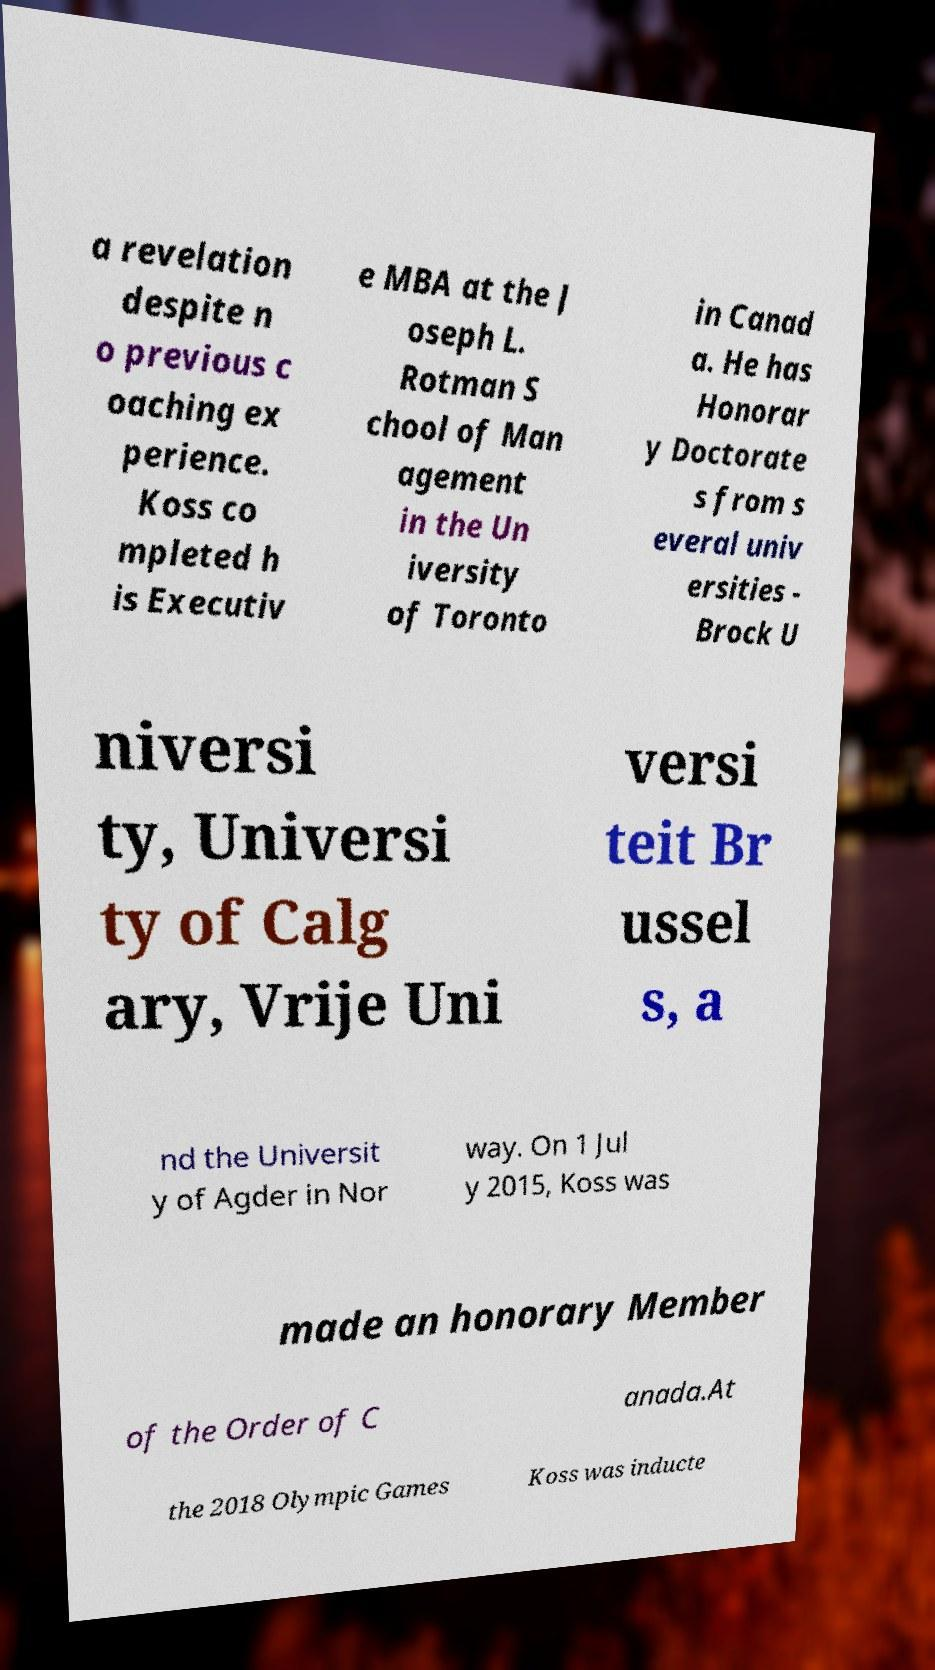Can you read and provide the text displayed in the image?This photo seems to have some interesting text. Can you extract and type it out for me? a revelation despite n o previous c oaching ex perience. Koss co mpleted h is Executiv e MBA at the J oseph L. Rotman S chool of Man agement in the Un iversity of Toronto in Canad a. He has Honorar y Doctorate s from s everal univ ersities - Brock U niversi ty, Universi ty of Calg ary, Vrije Uni versi teit Br ussel s, a nd the Universit y of Agder in Nor way. On 1 Jul y 2015, Koss was made an honorary Member of the Order of C anada.At the 2018 Olympic Games Koss was inducte 